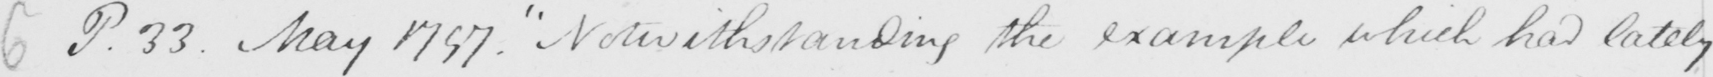Can you read and transcribe this handwriting? P.33 - May 1797 .  " Notwithstanding the example which had lately 